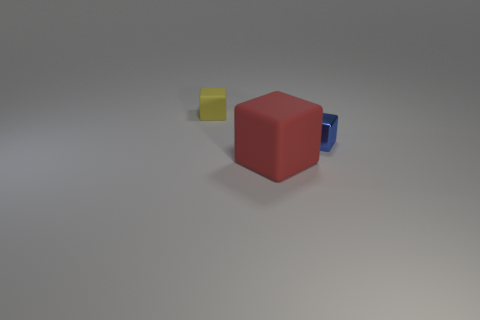Is the number of cubes that are in front of the shiny object greater than the number of large matte blocks that are in front of the red thing?
Offer a very short reply. Yes. There is a metal thing that is the same shape as the small matte object; what size is it?
Provide a succinct answer. Small. How many blocks are either small blue shiny objects or yellow things?
Offer a very short reply. 2. Are there fewer matte blocks that are in front of the small yellow rubber cube than objects on the left side of the metallic thing?
Your response must be concise. Yes. How many things are either small things left of the red thing or cyan blocks?
Offer a very short reply. 1. Is there a yellow thing of the same size as the blue metal cube?
Your answer should be compact. Yes. Is the number of small rubber things greater than the number of matte things?
Make the answer very short. No. Does the red thing right of the tiny yellow thing have the same size as the matte block left of the big matte cube?
Your answer should be very brief. No. How many matte cubes are in front of the tiny metallic block and to the left of the red object?
Offer a very short reply. 0. There is a shiny object that is the same shape as the large matte object; what color is it?
Give a very brief answer. Blue. 